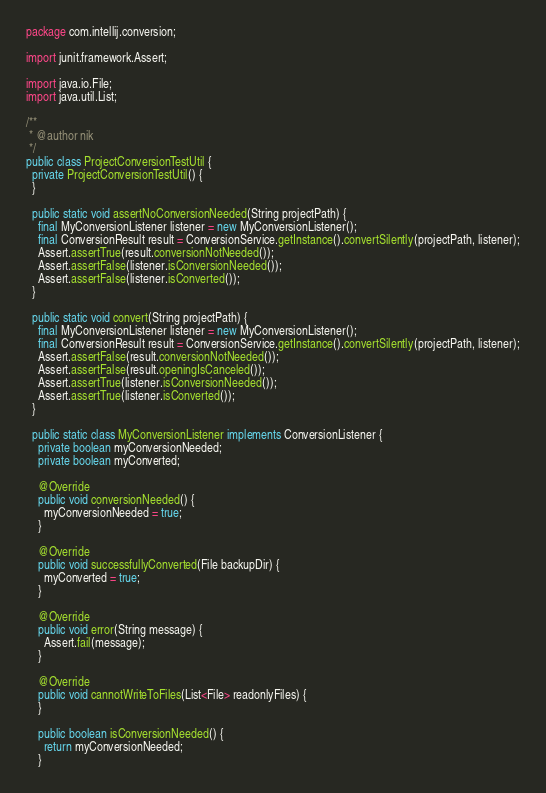Convert code to text. <code><loc_0><loc_0><loc_500><loc_500><_Java_>package com.intellij.conversion;

import junit.framework.Assert;

import java.io.File;
import java.util.List;

/**
 * @author nik
 */
public class ProjectConversionTestUtil {
  private ProjectConversionTestUtil() {
  }

  public static void assertNoConversionNeeded(String projectPath) {
    final MyConversionListener listener = new MyConversionListener();
    final ConversionResult result = ConversionService.getInstance().convertSilently(projectPath, listener);
    Assert.assertTrue(result.conversionNotNeeded());
    Assert.assertFalse(listener.isConversionNeeded());
    Assert.assertFalse(listener.isConverted());
  }

  public static void convert(String projectPath) {
    final MyConversionListener listener = new MyConversionListener();
    final ConversionResult result = ConversionService.getInstance().convertSilently(projectPath, listener);
    Assert.assertFalse(result.conversionNotNeeded());
    Assert.assertFalse(result.openingIsCanceled());
    Assert.assertTrue(listener.isConversionNeeded());
    Assert.assertTrue(listener.isConverted());
  }

  public static class MyConversionListener implements ConversionListener {
    private boolean myConversionNeeded;
    private boolean myConverted;

    @Override
    public void conversionNeeded() {
      myConversionNeeded = true;
    }

    @Override
    public void successfullyConverted(File backupDir) {
      myConverted = true;
    }

    @Override
    public void error(String message) {
      Assert.fail(message);
    }

    @Override
    public void cannotWriteToFiles(List<File> readonlyFiles) {
    }

    public boolean isConversionNeeded() {
      return myConversionNeeded;
    }
</code> 